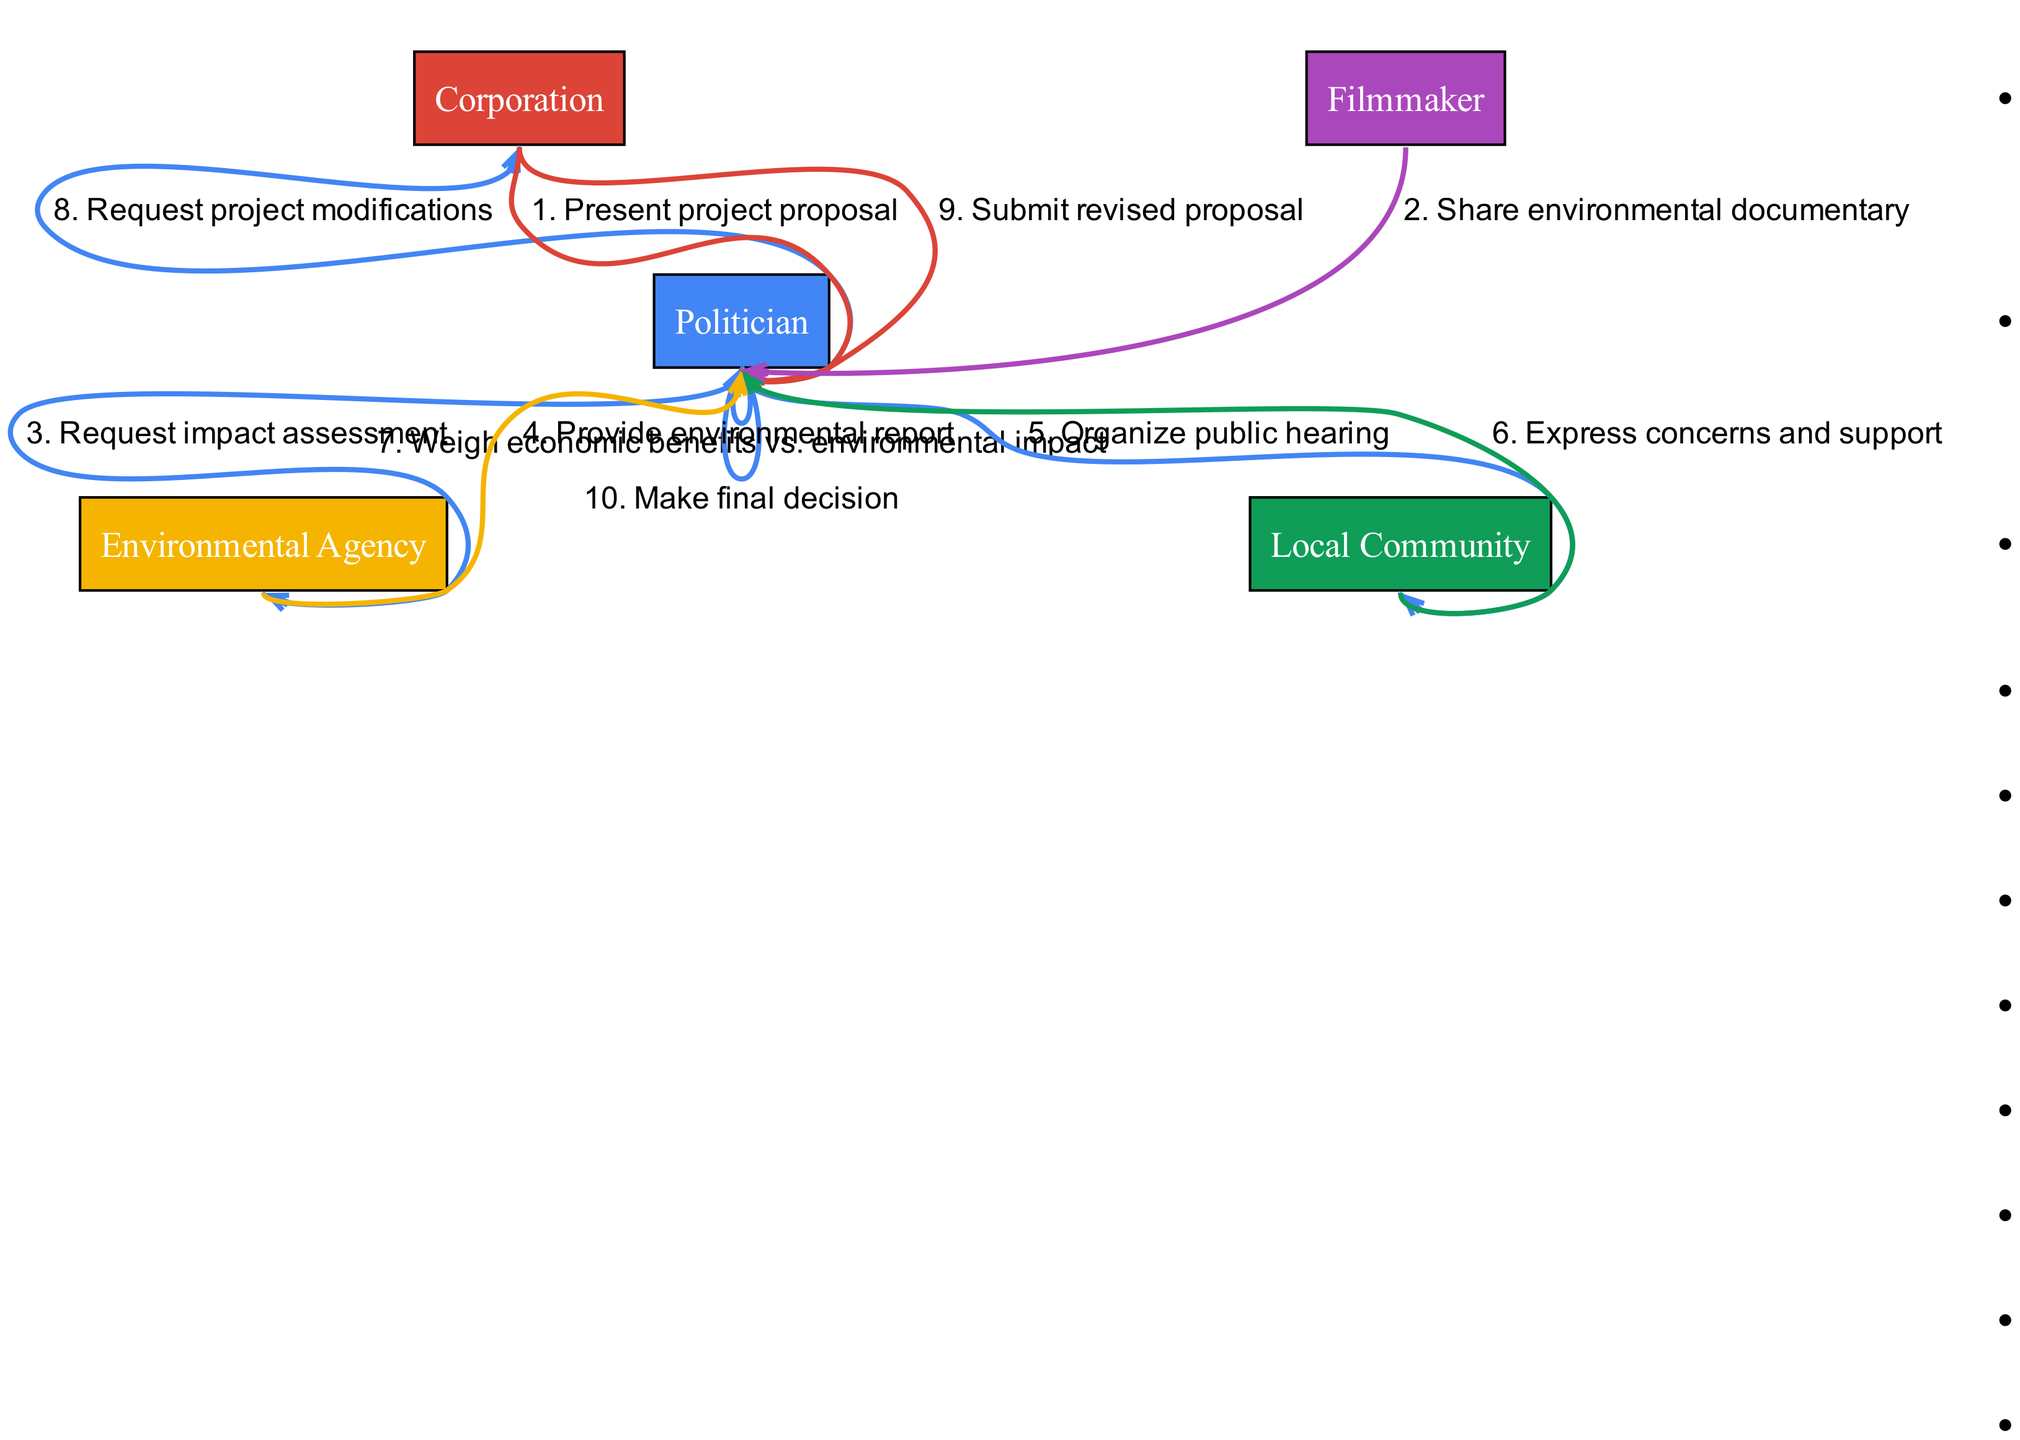What are the names of the actors involved? The actors specified in the sequence diagram are the Politician, Corporation, Environmental Agency, Local Community, and Filmmaker.
Answer: Politician, Corporation, Environmental Agency, Local Community, Filmmaker How many messages are sent in total? By counting each message in the sequence from the diagram, we see there are 10 messages exchanged among the actors.
Answer: 10 Who is the first actor to send a message? The sequence begins with the Corporation sending the initial message to the Politician, which is to present the project proposal.
Answer: Corporation What is the last action taken by the Politician? The final decision made by the Politician, outlined in the last step of the sequence, is to make a final decision regarding the project.
Answer: Make final decision Which actor expresses concerns and support? The Local Community is the actor that communicates concerns and support to the Politician, as indicated in the sequence.
Answer: Local Community What type of assessment does the Politician request? The Politician specifically requests an impact assessment, to be conducted by the Environmental Agency, as outlined in the sequence.
Answer: Impact assessment Which actor provides the environmental report? The Environmental Agency is responsible for providing the environmental report to the Politician, following the request made by the Politician.
Answer: Environmental Agency How many times does the Politician weigh economic benefits versus environmental impact? The Politician weighs economic benefits against environmental impact only once, as this is represented as a single message in the sequence.
Answer: Once What modification does the Politician request from the Corporation? The Politician requests modifications to the project from the Corporation after reviewing the information received from other actors and stakeholders.
Answer: Project modifications 